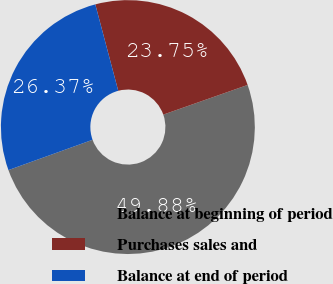Convert chart. <chart><loc_0><loc_0><loc_500><loc_500><pie_chart><fcel>Balance at beginning of period<fcel>Purchases sales and<fcel>Balance at end of period<nl><fcel>49.88%<fcel>23.75%<fcel>26.37%<nl></chart> 